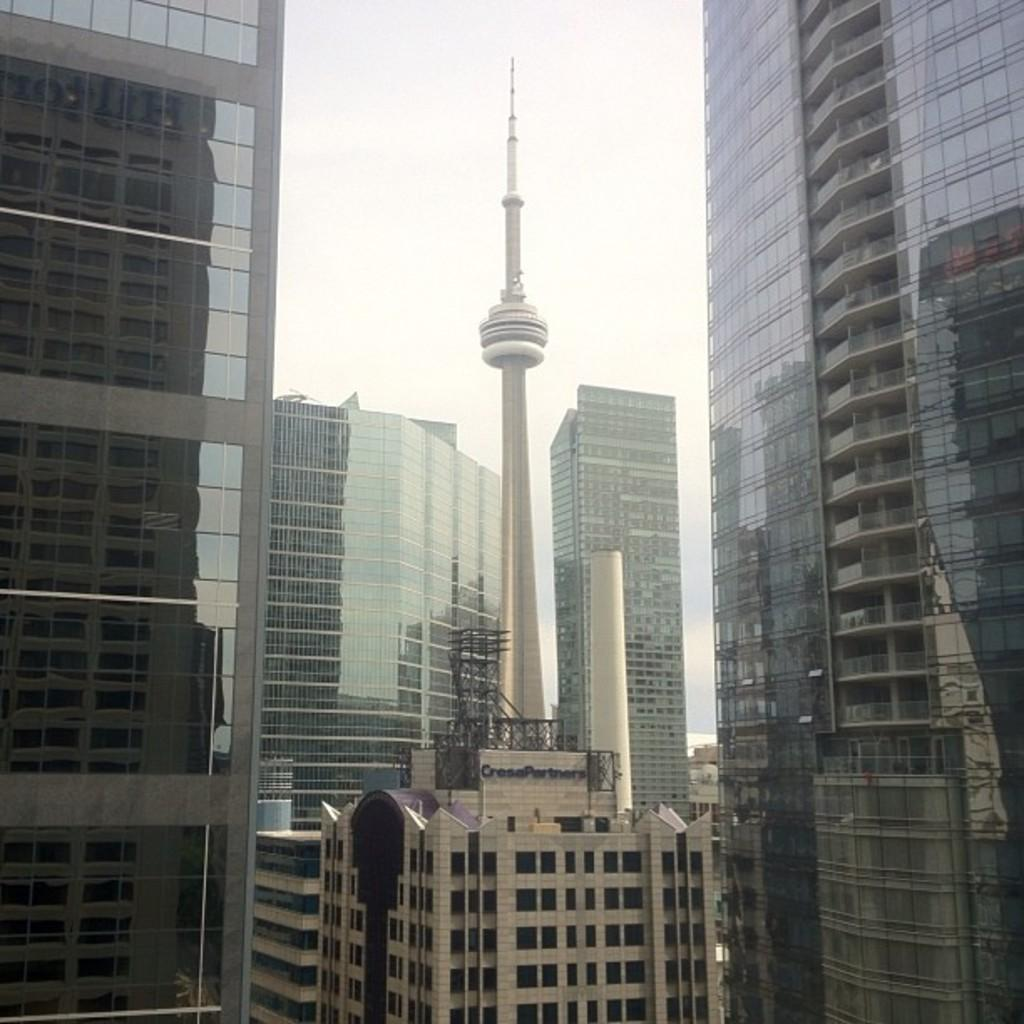What is written or displayed on the building in the image? There is text on a building in the image. What type of buildings can be seen in the background of the image? There are glass buildings visible in the background of the image. How many cows are visible in the image? There are no cows present in the image. What date is marked on the calendar in the image? There is no calendar present in the image. 